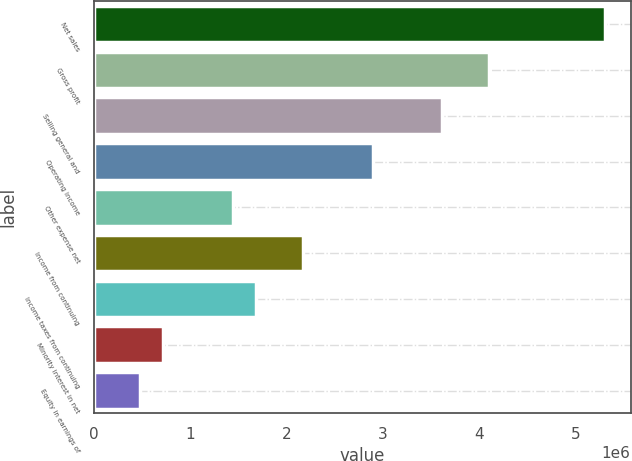Convert chart. <chart><loc_0><loc_0><loc_500><loc_500><bar_chart><fcel>Net sales<fcel>Gross profit<fcel>Selling general and<fcel>Operating income<fcel>Other expense net<fcel>Income from continuing<fcel>Income taxes from continuing<fcel>Minority interest in net<fcel>Equity in earnings of<nl><fcel>5.30871e+06<fcel>4.10218e+06<fcel>3.61957e+06<fcel>2.89566e+06<fcel>1.44783e+06<fcel>2.17175e+06<fcel>1.68914e+06<fcel>723916<fcel>482611<nl></chart> 